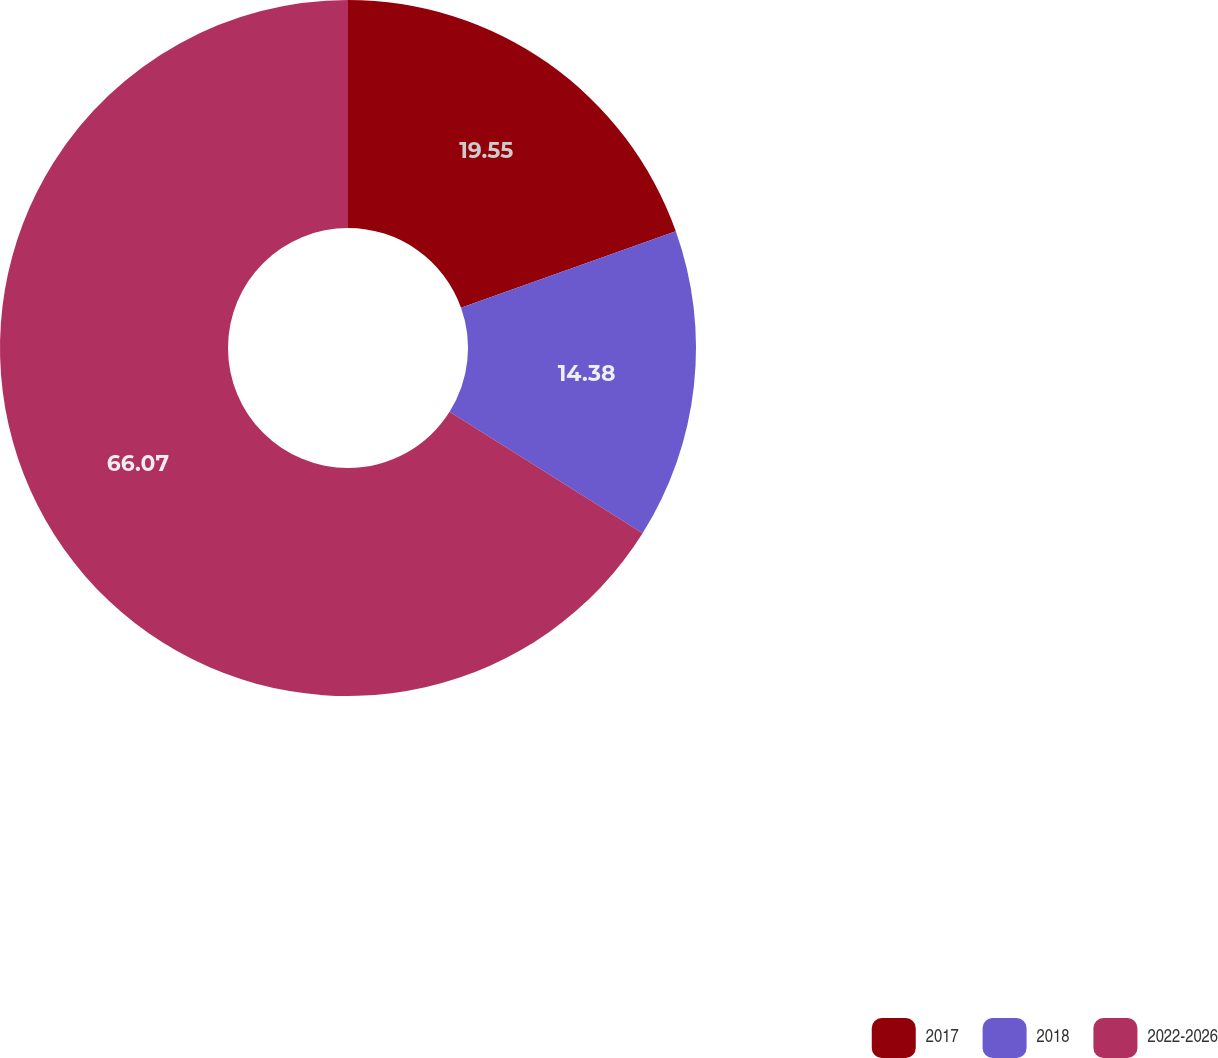<chart> <loc_0><loc_0><loc_500><loc_500><pie_chart><fcel>2017<fcel>2018<fcel>2022-2026<nl><fcel>19.55%<fcel>14.38%<fcel>66.06%<nl></chart> 